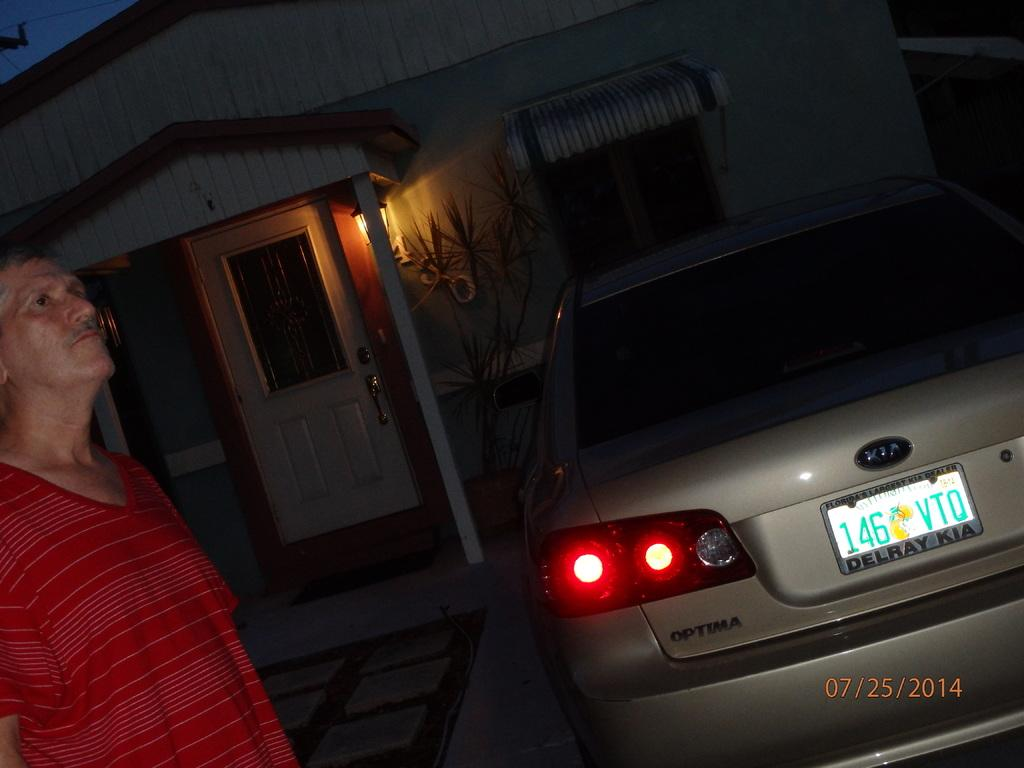Provide a one-sentence caption for the provided image. A car made by KIA has a license plate that reads "146VTO.". 